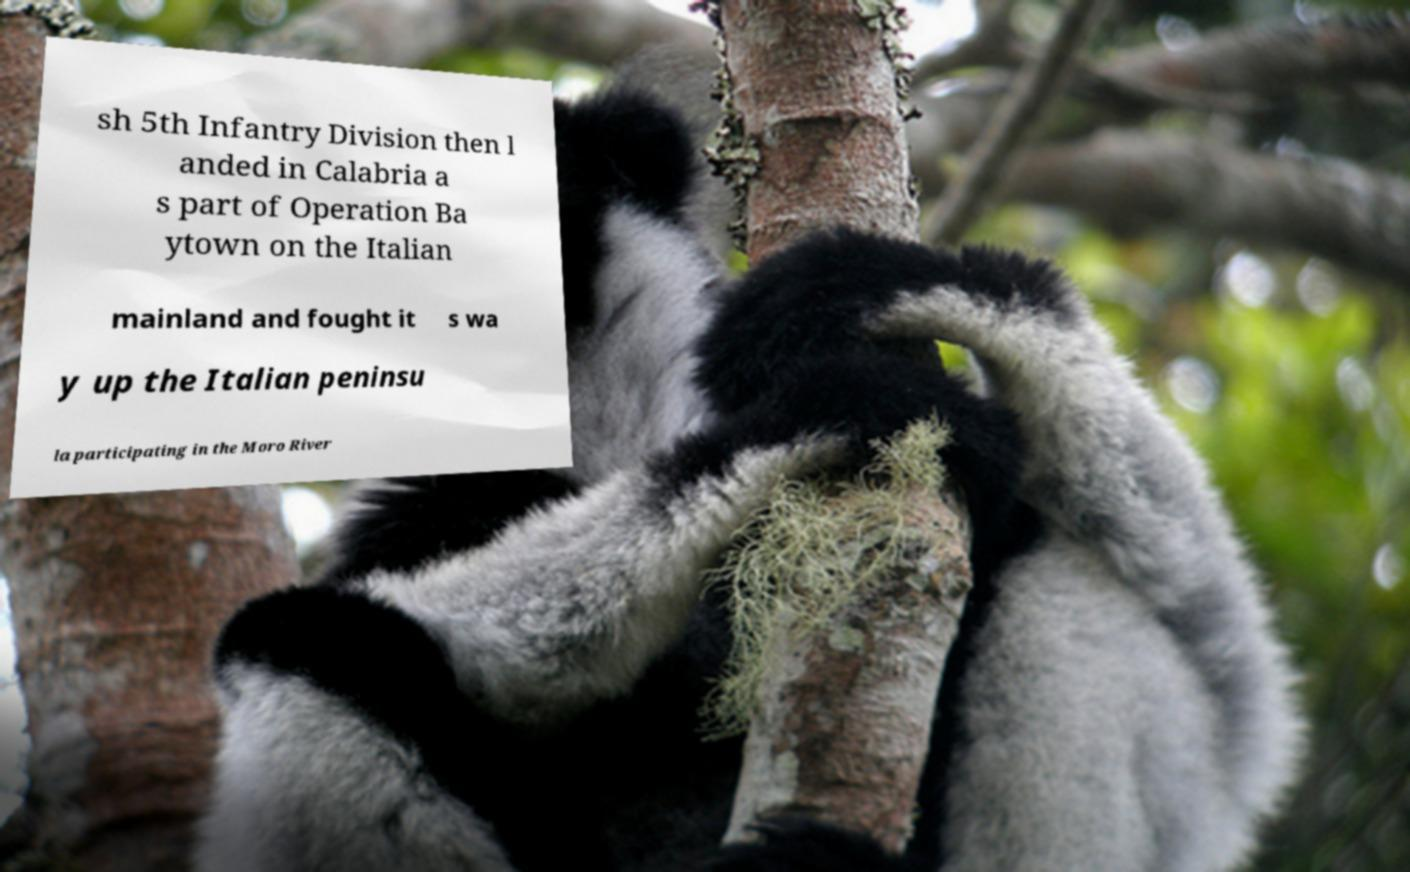Can you accurately transcribe the text from the provided image for me? sh 5th Infantry Division then l anded in Calabria a s part of Operation Ba ytown on the Italian mainland and fought it s wa y up the Italian peninsu la participating in the Moro River 